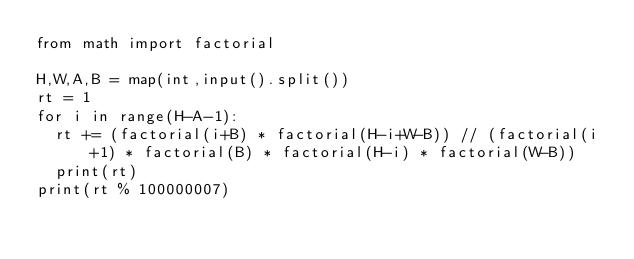<code> <loc_0><loc_0><loc_500><loc_500><_Python_>from math import factorial

H,W,A,B = map(int,input().split())
rt = 1
for i in range(H-A-1):
  rt += (factorial(i+B) * factorial(H-i+W-B)) // (factorial(i+1) * factorial(B) * factorial(H-i) * factorial(W-B))
  print(rt)
print(rt % 100000007)</code> 